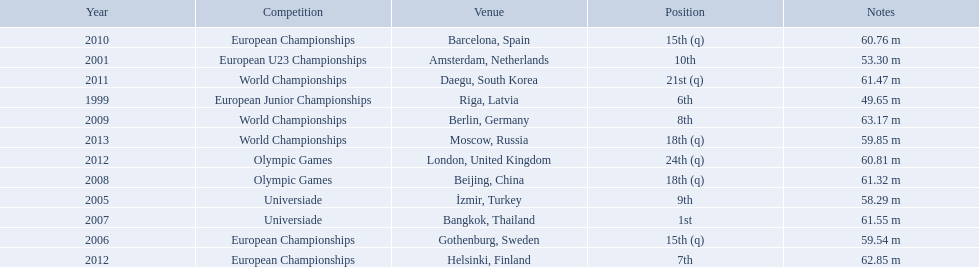What are the years that gerhard mayer participated? 1999, 2001, 2005, 2006, 2007, 2008, 2009, 2010, 2011, 2012, 2012, 2013. Which years were earlier than 2007? 1999, 2001, 2005, 2006. What was the best placing for these years? 6th. What european junior championships? 6th. What waseuropean junior championships best result? 63.17 m. 